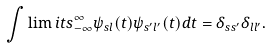<formula> <loc_0><loc_0><loc_500><loc_500>\int \lim i t s _ { - \infty } ^ { \infty } \psi _ { s l } ( t ) \psi _ { s ^ { \prime } l ^ { \prime } } ( t ) d t = \delta _ { s s ^ { \prime } } \delta _ { l l ^ { \prime } } .</formula> 